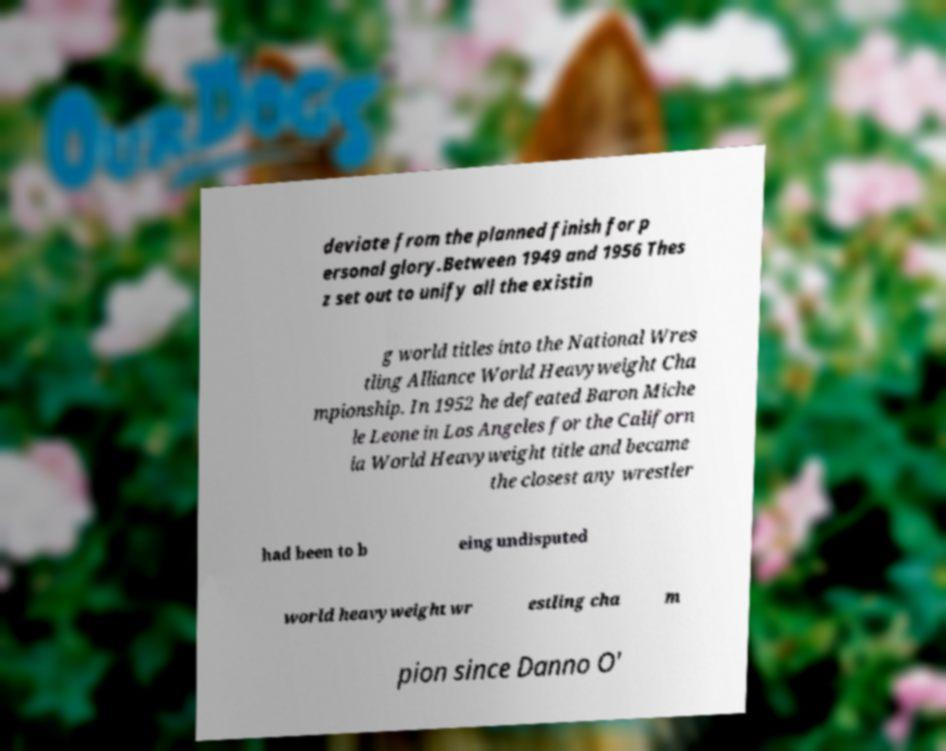I need the written content from this picture converted into text. Can you do that? deviate from the planned finish for p ersonal glory.Between 1949 and 1956 Thes z set out to unify all the existin g world titles into the National Wres tling Alliance World Heavyweight Cha mpionship. In 1952 he defeated Baron Miche le Leone in Los Angeles for the Californ ia World Heavyweight title and became the closest any wrestler had been to b eing undisputed world heavyweight wr estling cha m pion since Danno O' 